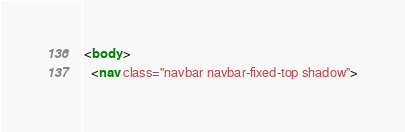<code> <loc_0><loc_0><loc_500><loc_500><_HTML_>
<body >
  <nav class="navbar navbar-fixed-top shadow"></code> 